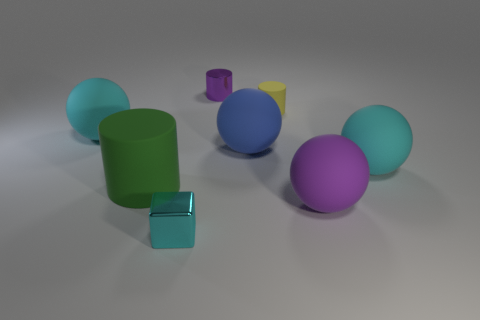Subtract all tiny matte cylinders. How many cylinders are left? 2 Add 1 large green matte cylinders. How many objects exist? 9 Subtract all green cylinders. How many cylinders are left? 2 Subtract all cubes. How many objects are left? 7 Add 4 tiny yellow cylinders. How many tiny yellow cylinders exist? 5 Subtract 0 yellow spheres. How many objects are left? 8 Subtract 1 blocks. How many blocks are left? 0 Subtract all red blocks. Subtract all gray balls. How many blocks are left? 1 Subtract all green cylinders. How many gray spheres are left? 0 Subtract all red spheres. Subtract all purple matte balls. How many objects are left? 7 